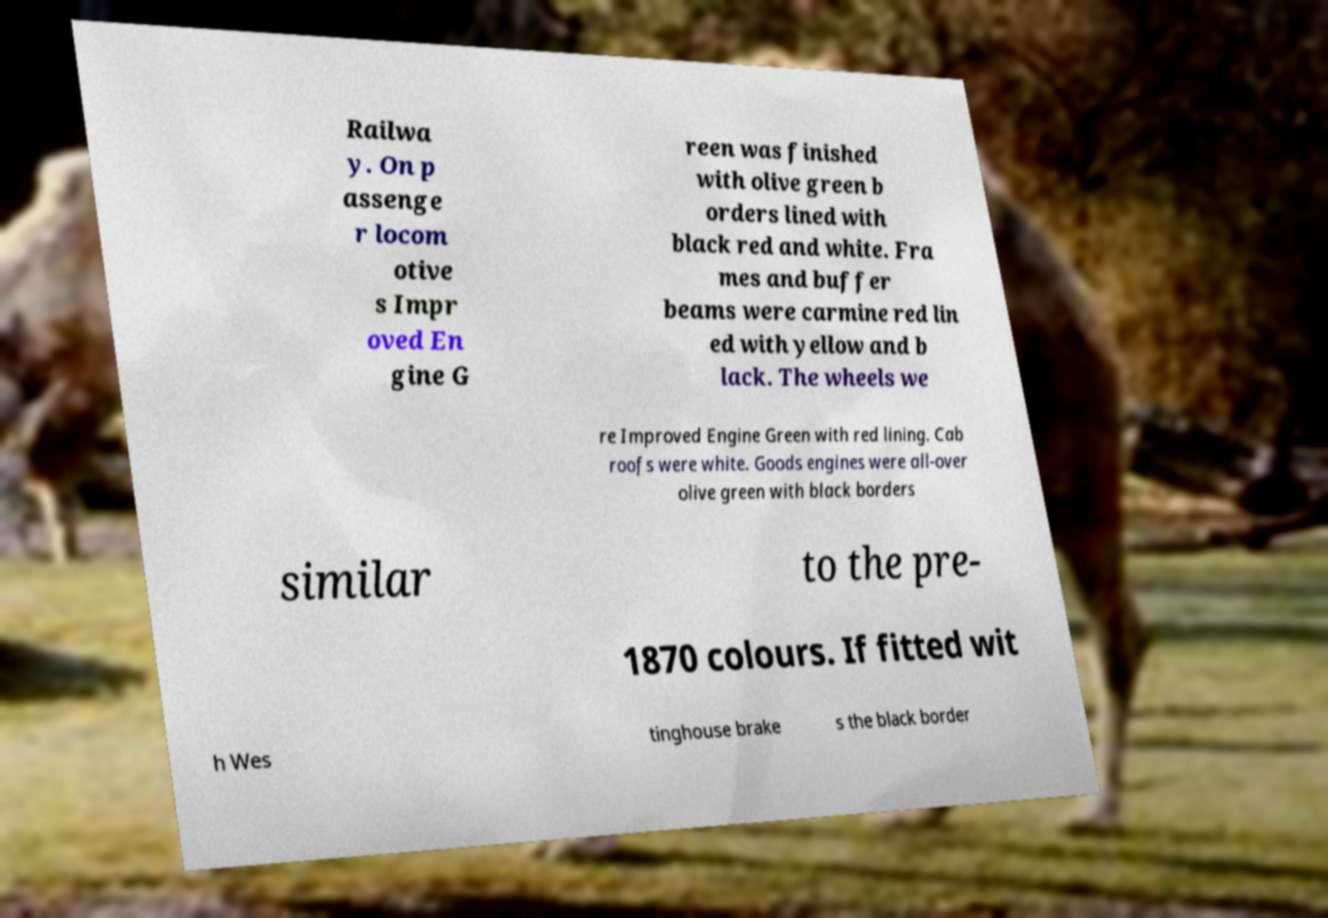What messages or text are displayed in this image? I need them in a readable, typed format. Railwa y. On p assenge r locom otive s Impr oved En gine G reen was finished with olive green b orders lined with black red and white. Fra mes and buffer beams were carmine red lin ed with yellow and b lack. The wheels we re Improved Engine Green with red lining. Cab roofs were white. Goods engines were all-over olive green with black borders similar to the pre- 1870 colours. If fitted wit h Wes tinghouse brake s the black border 